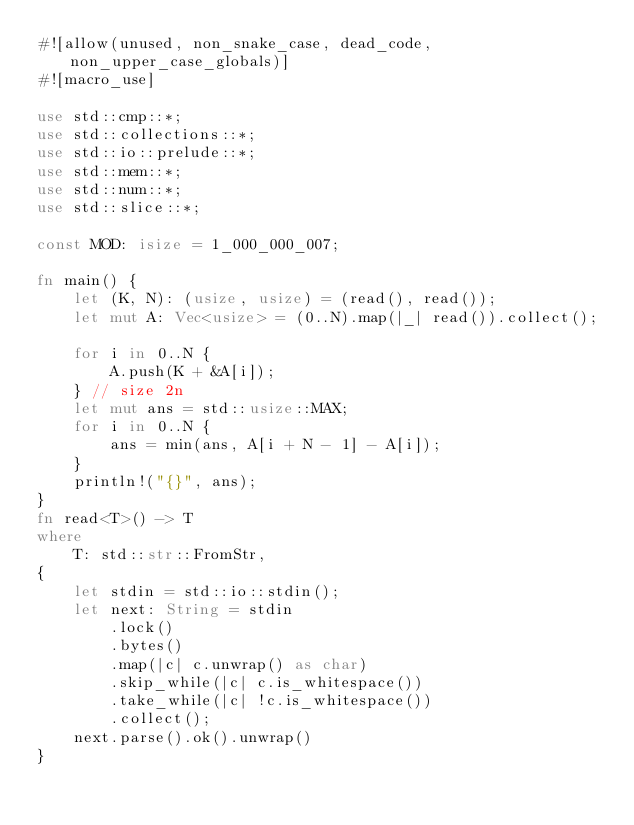Convert code to text. <code><loc_0><loc_0><loc_500><loc_500><_Rust_>#![allow(unused, non_snake_case, dead_code, non_upper_case_globals)]
#![macro_use]

use std::cmp::*;
use std::collections::*;
use std::io::prelude::*;
use std::mem::*;
use std::num::*;
use std::slice::*;

const MOD: isize = 1_000_000_007;

fn main() {
    let (K, N): (usize, usize) = (read(), read());
    let mut A: Vec<usize> = (0..N).map(|_| read()).collect();

    for i in 0..N {
        A.push(K + &A[i]);
    } // size 2n
    let mut ans = std::usize::MAX;
    for i in 0..N {
        ans = min(ans, A[i + N - 1] - A[i]);
    }
    println!("{}", ans);
}
fn read<T>() -> T
where
    T: std::str::FromStr,
{
    let stdin = std::io::stdin();
    let next: String = stdin
        .lock()
        .bytes()
        .map(|c| c.unwrap() as char)
        .skip_while(|c| c.is_whitespace())
        .take_while(|c| !c.is_whitespace())
        .collect();
    next.parse().ok().unwrap()
}
</code> 